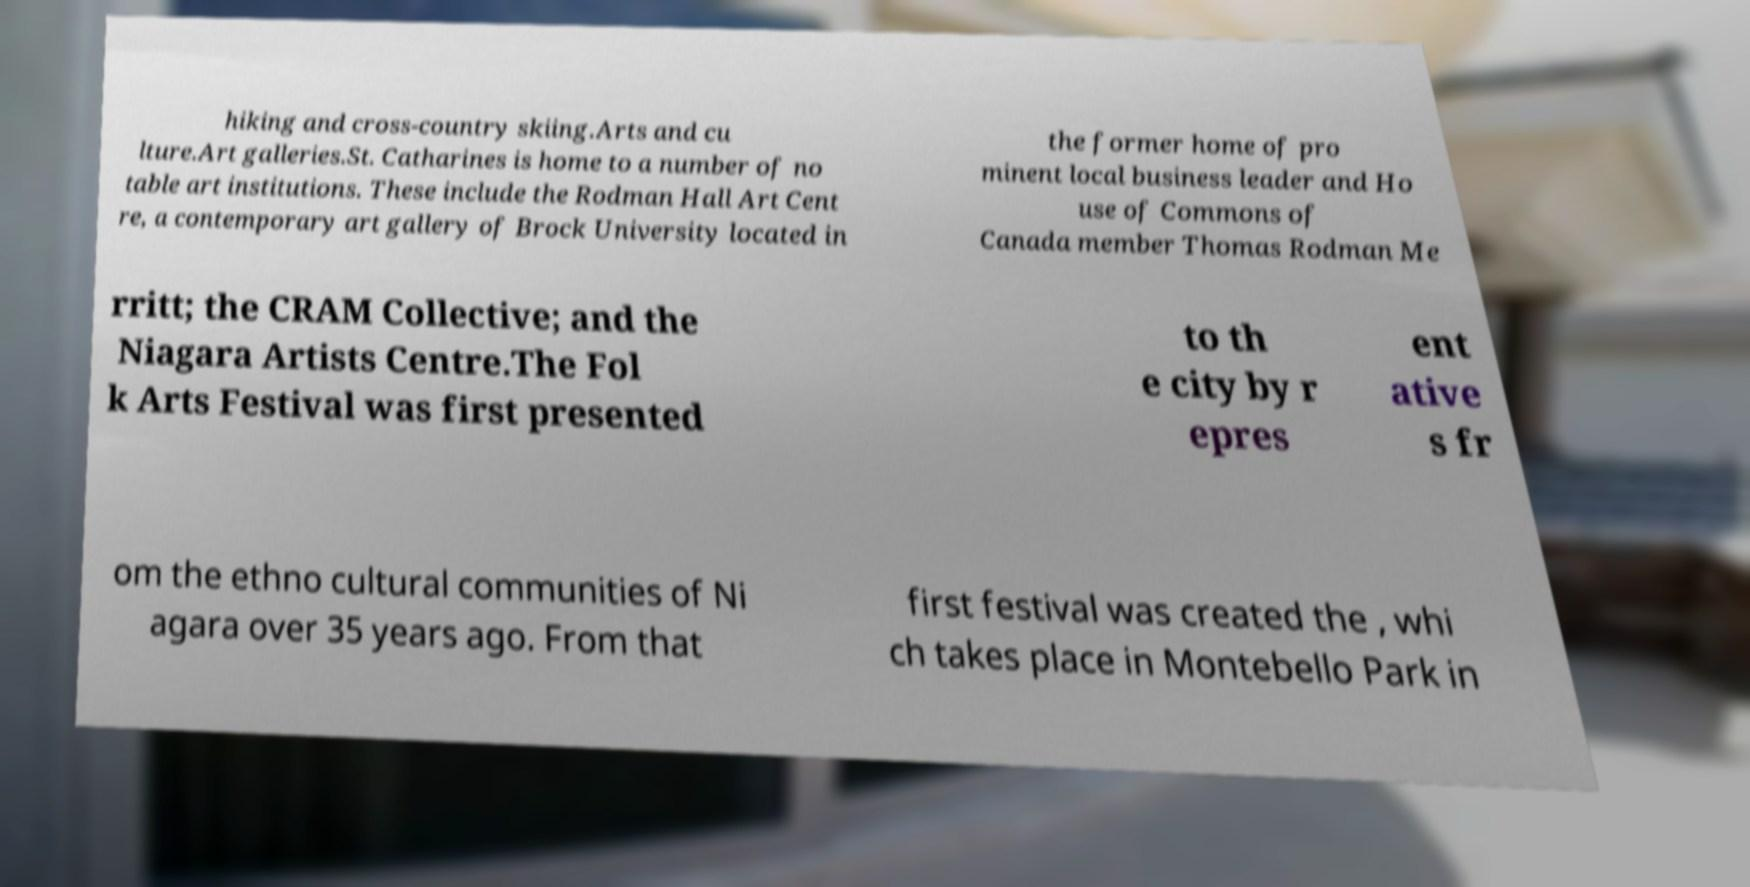Please identify and transcribe the text found in this image. hiking and cross-country skiing.Arts and cu lture.Art galleries.St. Catharines is home to a number of no table art institutions. These include the Rodman Hall Art Cent re, a contemporary art gallery of Brock University located in the former home of pro minent local business leader and Ho use of Commons of Canada member Thomas Rodman Me rritt; the CRAM Collective; and the Niagara Artists Centre.The Fol k Arts Festival was first presented to th e city by r epres ent ative s fr om the ethno cultural communities of Ni agara over 35 years ago. From that first festival was created the , whi ch takes place in Montebello Park in 